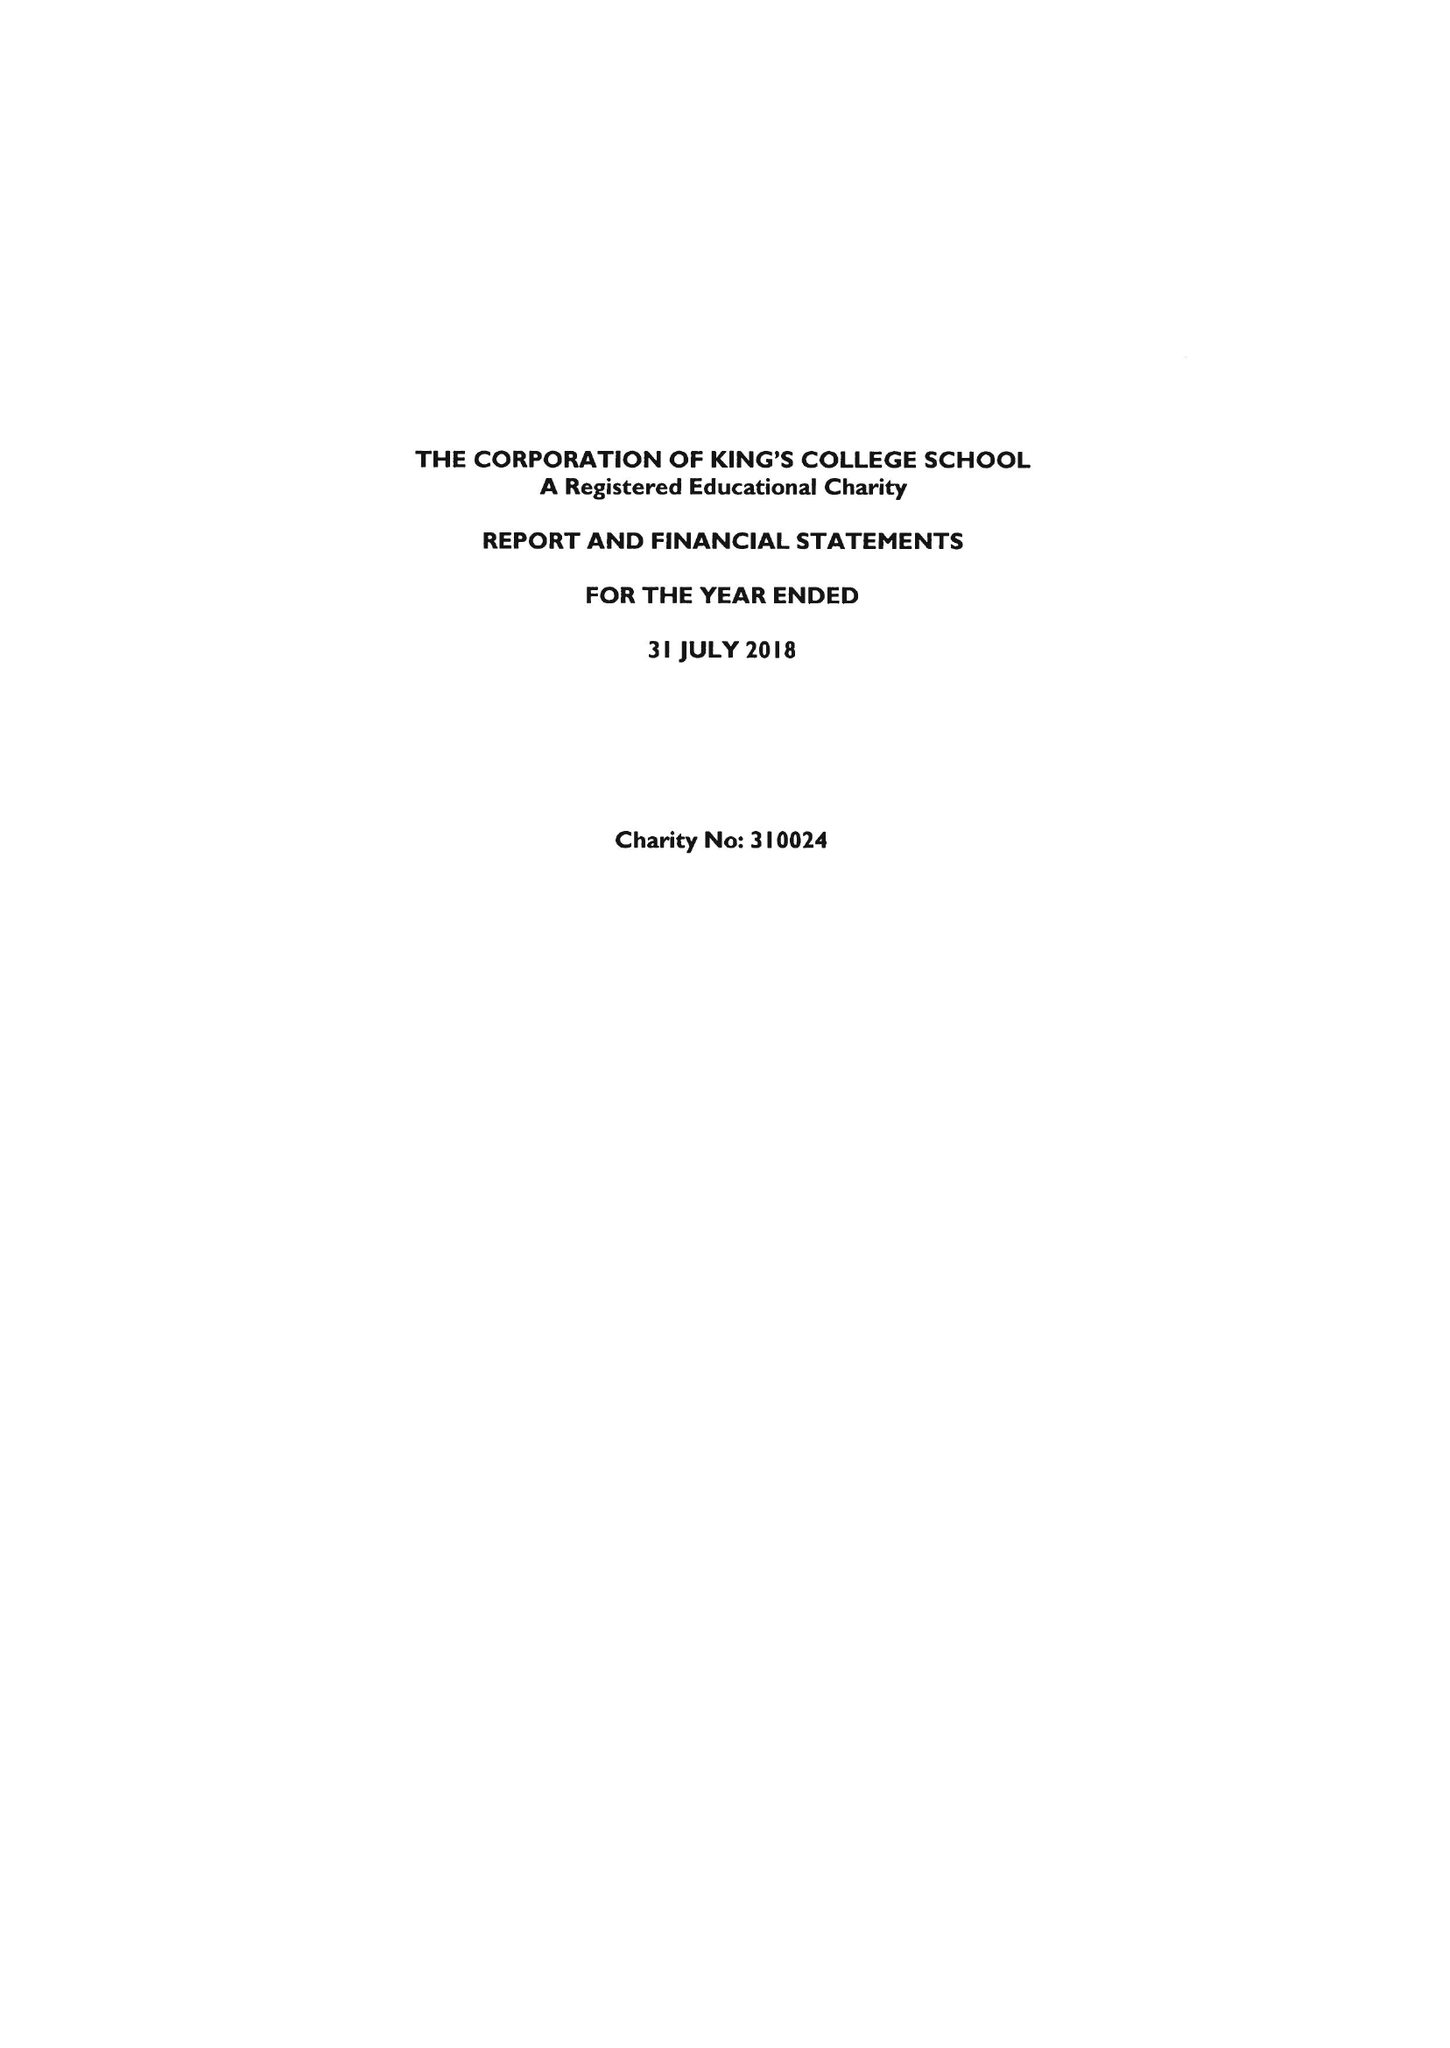What is the value for the address__postcode?
Answer the question using a single word or phrase. SW19 4TT 